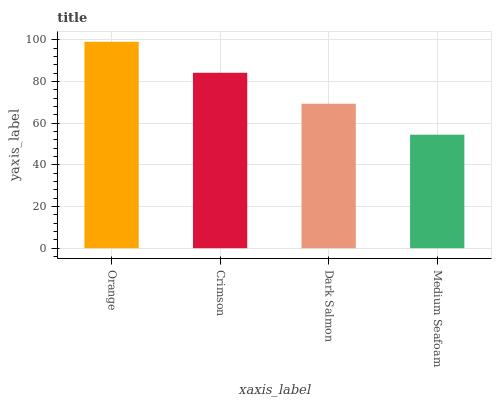Is Medium Seafoam the minimum?
Answer yes or no. Yes. Is Orange the maximum?
Answer yes or no. Yes. Is Crimson the minimum?
Answer yes or no. No. Is Crimson the maximum?
Answer yes or no. No. Is Orange greater than Crimson?
Answer yes or no. Yes. Is Crimson less than Orange?
Answer yes or no. Yes. Is Crimson greater than Orange?
Answer yes or no. No. Is Orange less than Crimson?
Answer yes or no. No. Is Crimson the high median?
Answer yes or no. Yes. Is Dark Salmon the low median?
Answer yes or no. Yes. Is Dark Salmon the high median?
Answer yes or no. No. Is Medium Seafoam the low median?
Answer yes or no. No. 